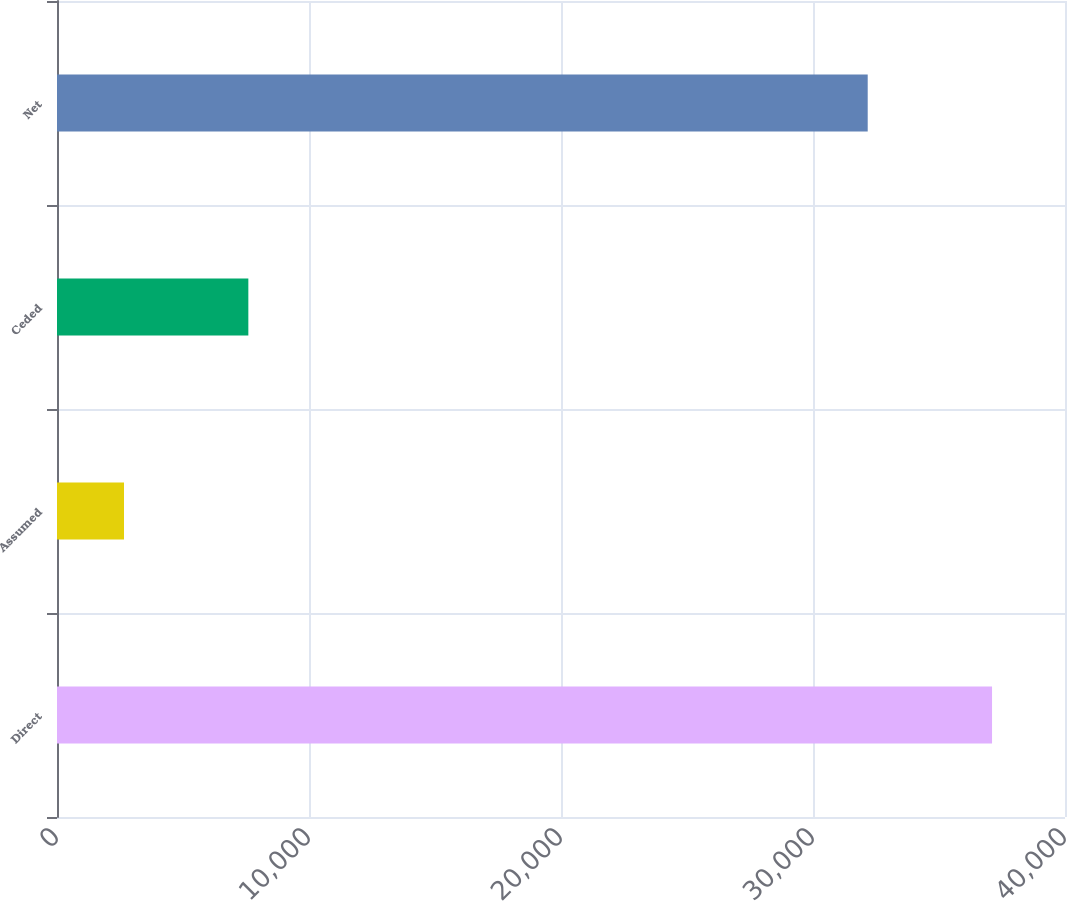<chart> <loc_0><loc_0><loc_500><loc_500><bar_chart><fcel>Direct<fcel>Assumed<fcel>Ceded<fcel>Net<nl><fcel>37105<fcel>2659<fcel>7593<fcel>32171<nl></chart> 